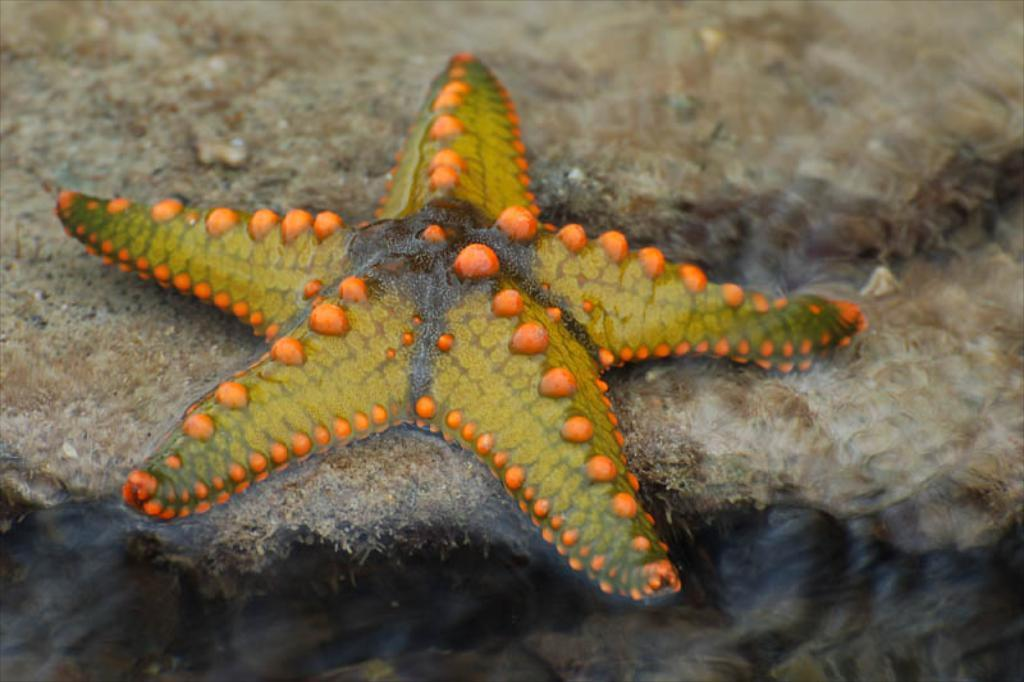What type of animal is in the image? There is an aquatic animal in the image. What colors can be seen on the animal? The animal has green, orange, and black colors. What is the color of the background in the image? The background of the image is brown. How many straws are being used by the women in the image? There are no women or straws present in the image; it features an aquatic animal with specific colors against a brown background. 